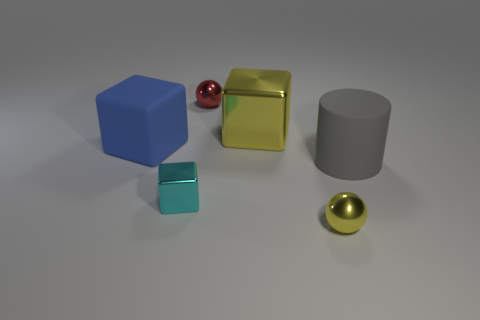Subtract all rubber blocks. How many blocks are left? 2 Subtract 1 blocks. How many blocks are left? 2 Add 4 large matte things. How many objects exist? 10 Subtract all spheres. How many objects are left? 4 Add 5 large rubber cubes. How many large rubber cubes are left? 6 Add 5 yellow shiny cubes. How many yellow shiny cubes exist? 6 Subtract 0 green spheres. How many objects are left? 6 Subtract all small yellow balls. Subtract all cyan blocks. How many objects are left? 4 